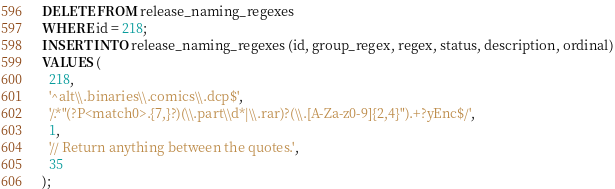Convert code to text. <code><loc_0><loc_0><loc_500><loc_500><_SQL_>DELETE FROM release_naming_regexes
WHERE id = 218;
INSERT INTO release_naming_regexes (id, group_regex, regex, status, description, ordinal)
VALUES (
  218,
  '^alt\\.binaries\\.comics\\.dcp$',
  '/.*"(?P<match0>.{7,}?)(\\.part\\d*|\\.rar)?(\\.[A-Za-z0-9]{2,4}").+?yEnc$/',
  1,
  '// Return anything between the quotes.',
  35
);</code> 